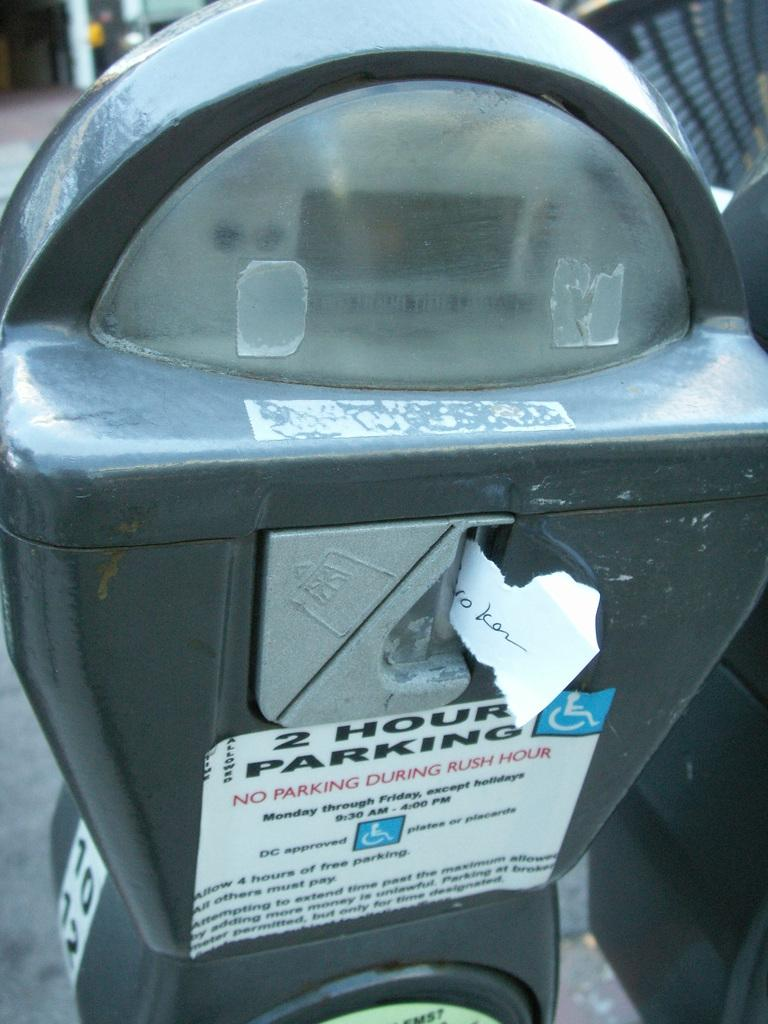Provide a one-sentence caption for the provided image. 2 hour packing, but don't park during rush hour. 